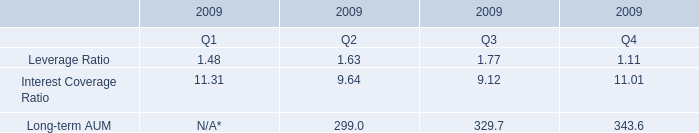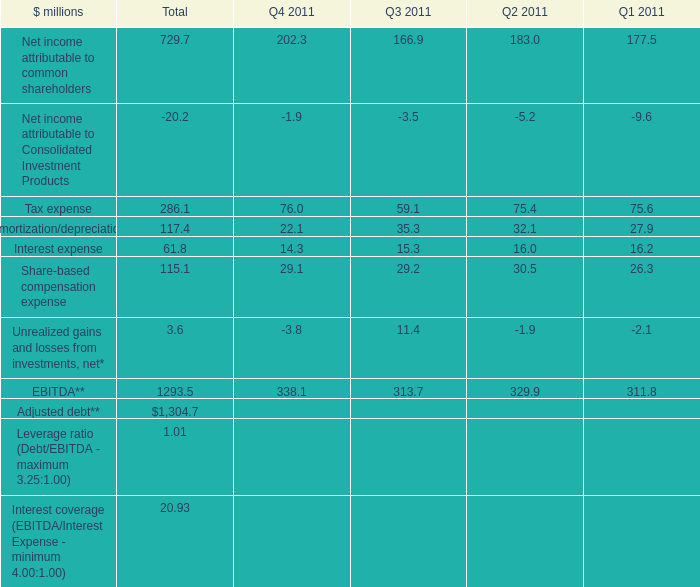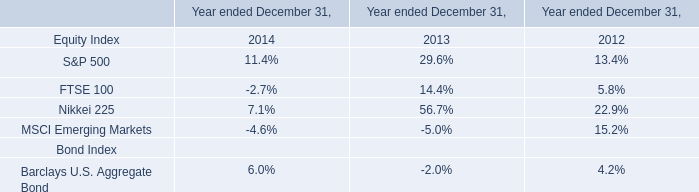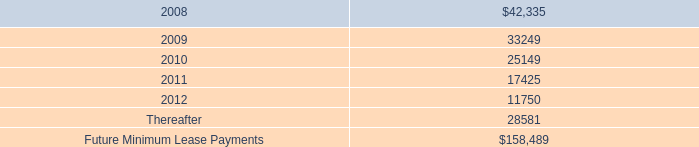What is the sum of Share-based compensation expense in the range of 20 and 30 in 2011? (in million) 
Computations: ((29.1 + 29.2) + 26.3)
Answer: 84.6. 